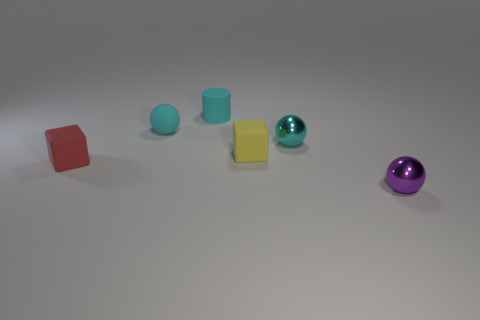Does the cylinder have the same material as the small purple object?
Keep it short and to the point. No. Does the rubber ball have the same color as the matte cylinder?
Your answer should be very brief. Yes. There is another tiny ball that is the same color as the small matte ball; what is its material?
Give a very brief answer. Metal. What size is the shiny object that is on the left side of the tiny purple thing?
Keep it short and to the point. Small. What number of objects are either cubes or small matte objects on the left side of the cyan cylinder?
Offer a terse response. 3. What number of other objects are there of the same size as the cyan rubber cylinder?
Your answer should be very brief. 5. What is the material of the other thing that is the same shape as the yellow matte thing?
Give a very brief answer. Rubber. Are there more tiny cyan shiny things that are right of the red rubber thing than gray matte objects?
Ensure brevity in your answer.  Yes. Are there any other things that have the same color as the tiny matte ball?
Your response must be concise. Yes. There is a tiny cyan thing that is made of the same material as the small cylinder; what shape is it?
Provide a succinct answer. Sphere. 